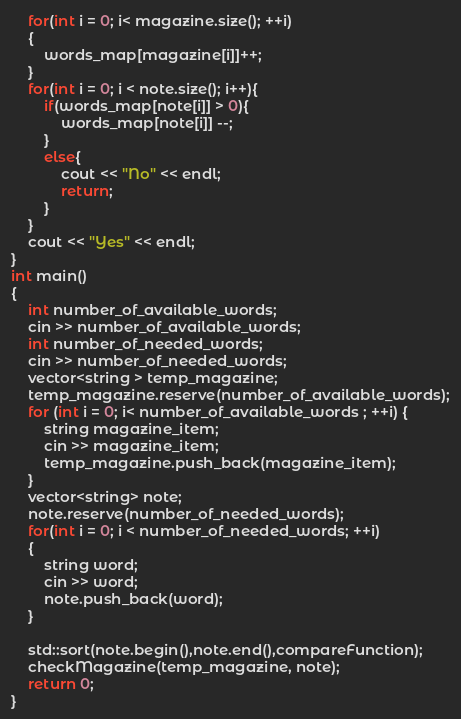Convert code to text. <code><loc_0><loc_0><loc_500><loc_500><_C++_>    for(int i = 0; i< magazine.size(); ++i)
    {
        words_map[magazine[i]]++;
    }
    for(int i = 0; i < note.size(); i++){
        if(words_map[note[i]] > 0){
            words_map[note[i]] --;
        }
        else{
            cout << "No" << endl;
            return;
        }
    }
    cout << "Yes" << endl;
}
int main()
{
    int number_of_available_words;
    cin >> number_of_available_words;
    int number_of_needed_words;
    cin >> number_of_needed_words;
    vector<string > temp_magazine;
    temp_magazine.reserve(number_of_available_words);
    for (int i = 0; i< number_of_available_words ; ++i) {
        string magazine_item;
        cin >> magazine_item;
        temp_magazine.push_back(magazine_item);
    }
    vector<string> note;
    note.reserve(number_of_needed_words);
    for(int i = 0; i < number_of_needed_words; ++i)
    {
        string word;
        cin >> word;
        note.push_back(word);
    }
   
    std::sort(note.begin(),note.end(),compareFunction);
    checkMagazine(temp_magazine, note);
    return 0;
}
</code> 